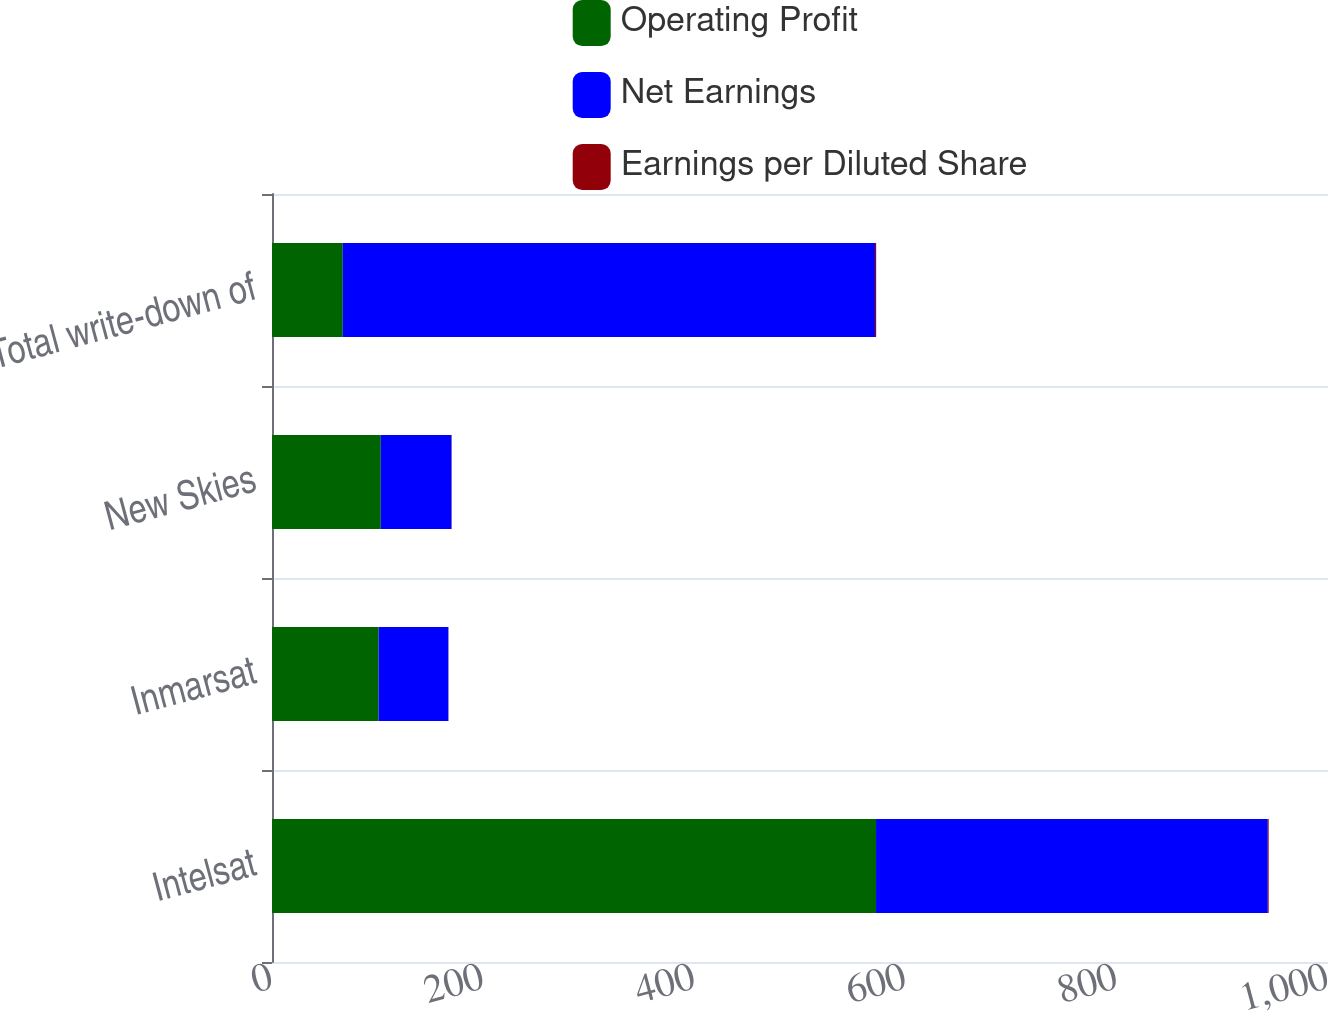Convert chart. <chart><loc_0><loc_0><loc_500><loc_500><stacked_bar_chart><ecel><fcel>Intelsat<fcel>Inmarsat<fcel>New Skies<fcel>Total write-down of<nl><fcel>Operating Profit<fcel>572<fcel>101<fcel>103<fcel>67<nl><fcel>Net Earnings<fcel>371<fcel>66<fcel>67<fcel>504<nl><fcel>Earnings per Diluted Share<fcel>0.82<fcel>0.15<fcel>0.15<fcel>1.12<nl></chart> 